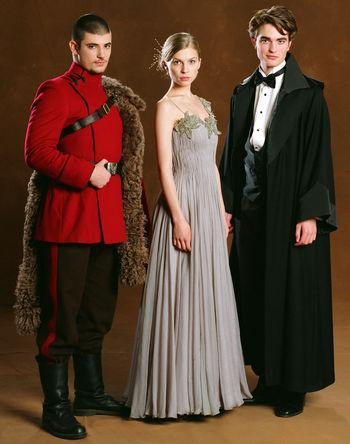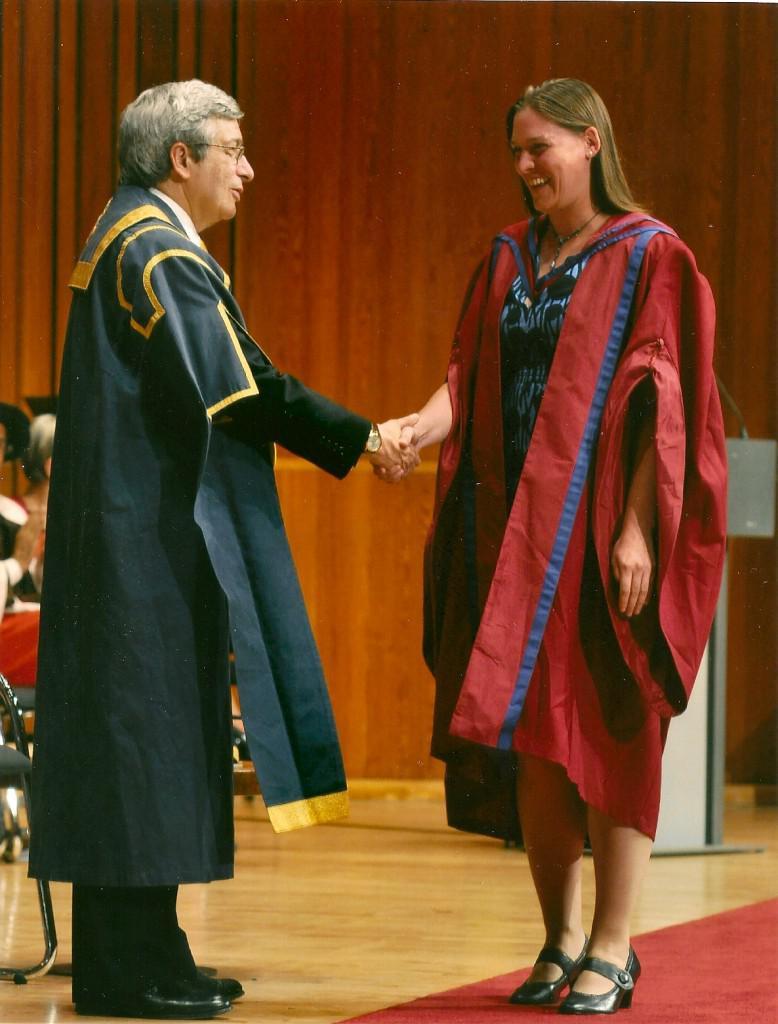The first image is the image on the left, the second image is the image on the right. For the images displayed, is the sentence "An image shows a woman in a burgundy graduation robe next to a man in a bright red robe with pink and burgundy sashes." factually correct? Answer yes or no. No. The first image is the image on the left, the second image is the image on the right. Evaluate the accuracy of this statement regarding the images: "The right image contains no more than two people wearing graduation gowns.". Is it true? Answer yes or no. Yes. 